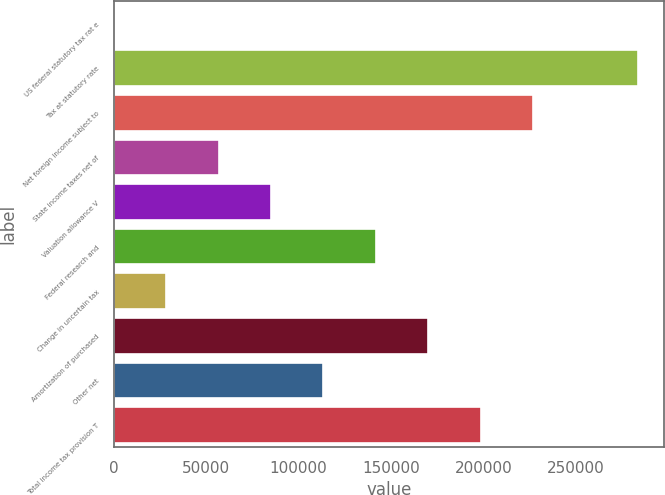Convert chart. <chart><loc_0><loc_0><loc_500><loc_500><bar_chart><fcel>US federal statutory tax rat e<fcel>Tax at statutory rate<fcel>Net foreign income subject to<fcel>State income taxes net of<fcel>Valuation allowance V<fcel>Federal research and<fcel>Change in uncertain tax<fcel>Amortization of purchased<fcel>Other net<fcel>Total income tax provision T<nl><fcel>35<fcel>283540<fcel>226839<fcel>56736<fcel>85086.5<fcel>141788<fcel>28385.5<fcel>170138<fcel>113437<fcel>198488<nl></chart> 